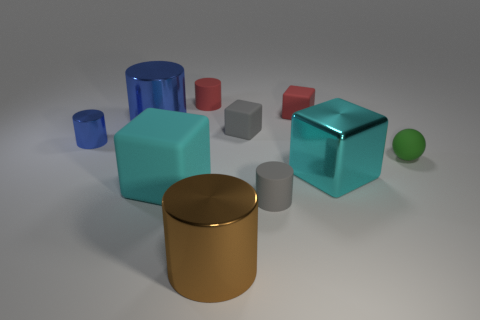There is a small gray rubber thing that is in front of the large thing on the right side of the large brown metallic object; how many big objects are on the right side of it?
Keep it short and to the point. 1. There is another cylinder that is the same color as the small shiny cylinder; what is it made of?
Make the answer very short. Metal. Are there any other things that are the same shape as the green thing?
Give a very brief answer. No. What number of objects are tiny cylinders right of the tiny gray rubber cube or big cyan spheres?
Your answer should be compact. 1. There is a big thing to the left of the large cyan rubber block; is its color the same as the small metallic cylinder?
Give a very brief answer. Yes. What shape is the big cyan thing that is right of the gray object that is in front of the small green matte object?
Your answer should be very brief. Cube. Is the number of gray objects that are left of the brown metallic thing less than the number of matte cubes in front of the tiny metal cylinder?
Give a very brief answer. Yes. The gray rubber thing that is the same shape as the brown object is what size?
Ensure brevity in your answer.  Small. How many things are tiny gray rubber objects that are behind the tiny gray cylinder or cubes that are to the right of the small blue cylinder?
Your response must be concise. 4. Do the green sphere and the gray matte cylinder have the same size?
Keep it short and to the point. Yes. 